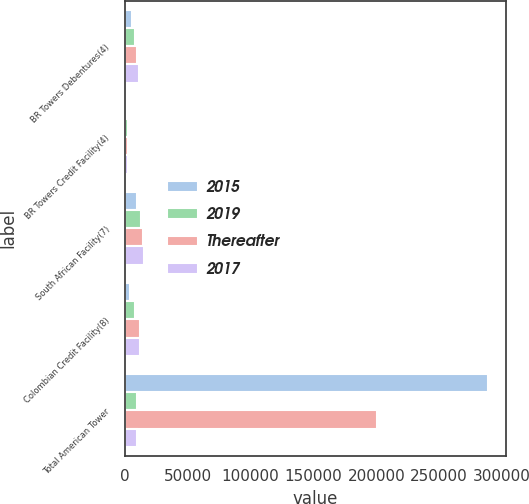Convert chart to OTSL. <chart><loc_0><loc_0><loc_500><loc_500><stacked_bar_chart><ecel><fcel>BR Towers Debentures(4)<fcel>BR Towers Credit Facility(4)<fcel>South African Facility(7)<fcel>Colombian Credit Facility(8)<fcel>Total American Tower<nl><fcel>2015<fcel>5623<fcel>1198<fcel>9448<fcel>4180<fcel>288810<nl><fcel>2019<fcel>8026<fcel>2874<fcel>13145<fcel>8360<fcel>9676<nl><fcel>Thereafter<fcel>9904<fcel>2874<fcel>14788<fcel>12539<fcel>200608<nl><fcel>2017<fcel>11428<fcel>2874<fcel>15610<fcel>12539<fcel>9676<nl></chart> 